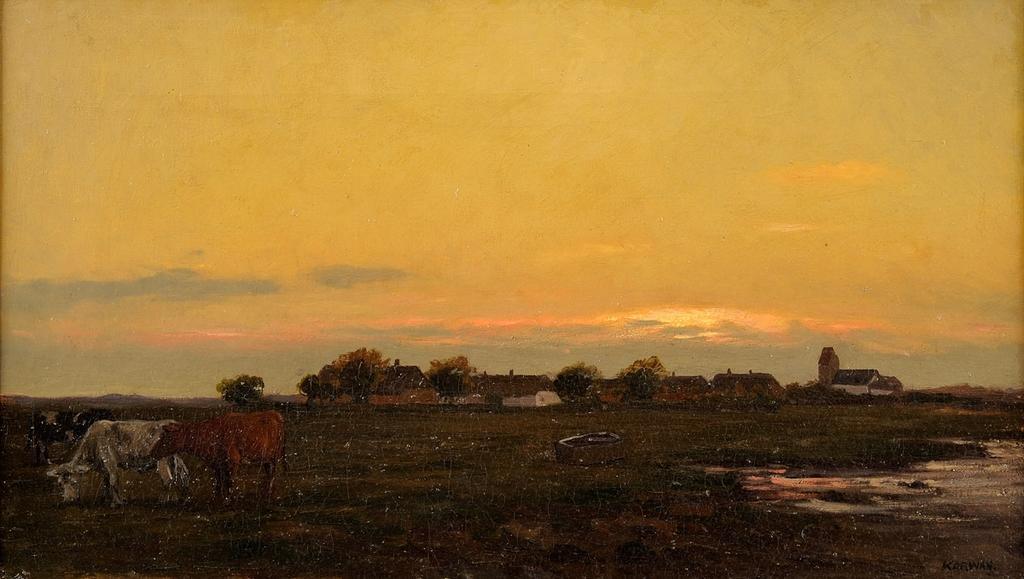Could you give a brief overview of what you see in this image? This is a photo and here we can see animals, trees, houses and there is an object. At the top, there is sky and at the bottom, there is ground and water. 